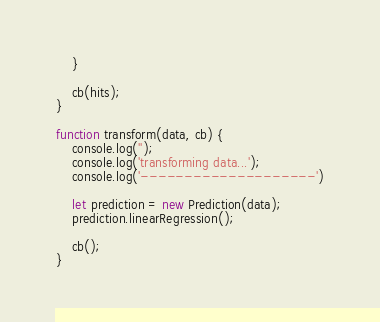<code> <loc_0><loc_0><loc_500><loc_500><_JavaScript_>	}

	cb(hits);
}

function transform(data, cb) {
	console.log('');
	console.log('transforming data...');
	console.log('--------------------')

	let prediction = new Prediction(data);
	prediction.linearRegression();

	cb();
}</code> 